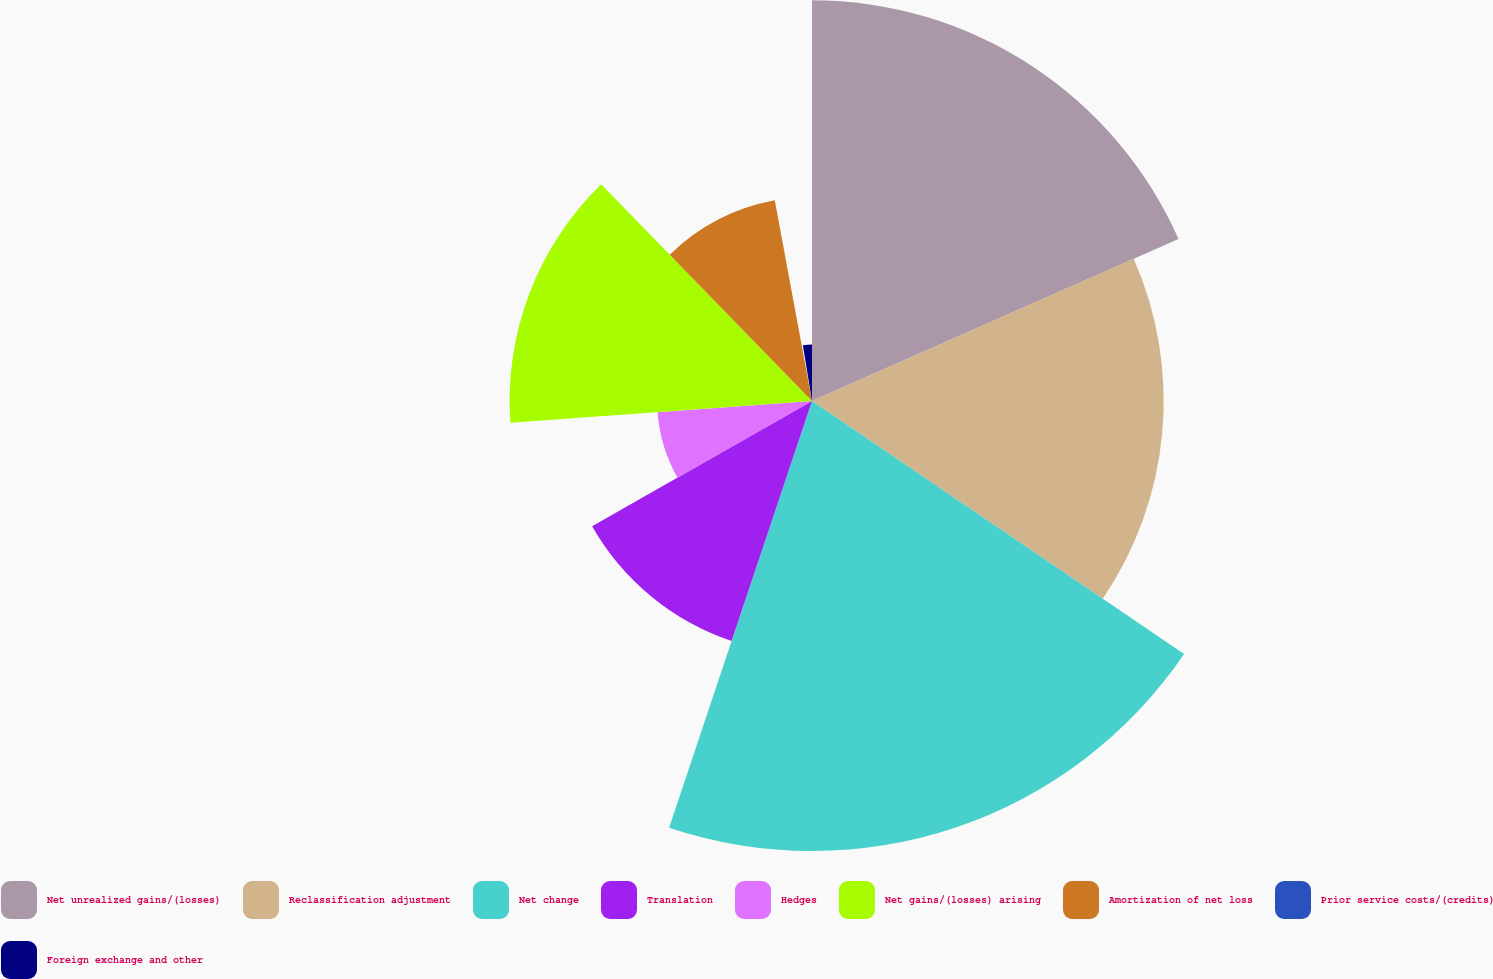Convert chart to OTSL. <chart><loc_0><loc_0><loc_500><loc_500><pie_chart><fcel>Net unrealized gains/(losses)<fcel>Reclassification adjustment<fcel>Net change<fcel>Translation<fcel>Hedges<fcel>Net gains/(losses) arising<fcel>Amortization of net loss<fcel>Prior service costs/(credits)<fcel>Foreign exchange and other<nl><fcel>18.38%<fcel>16.13%<fcel>20.64%<fcel>11.61%<fcel>7.1%<fcel>13.87%<fcel>9.36%<fcel>0.33%<fcel>2.59%<nl></chart> 